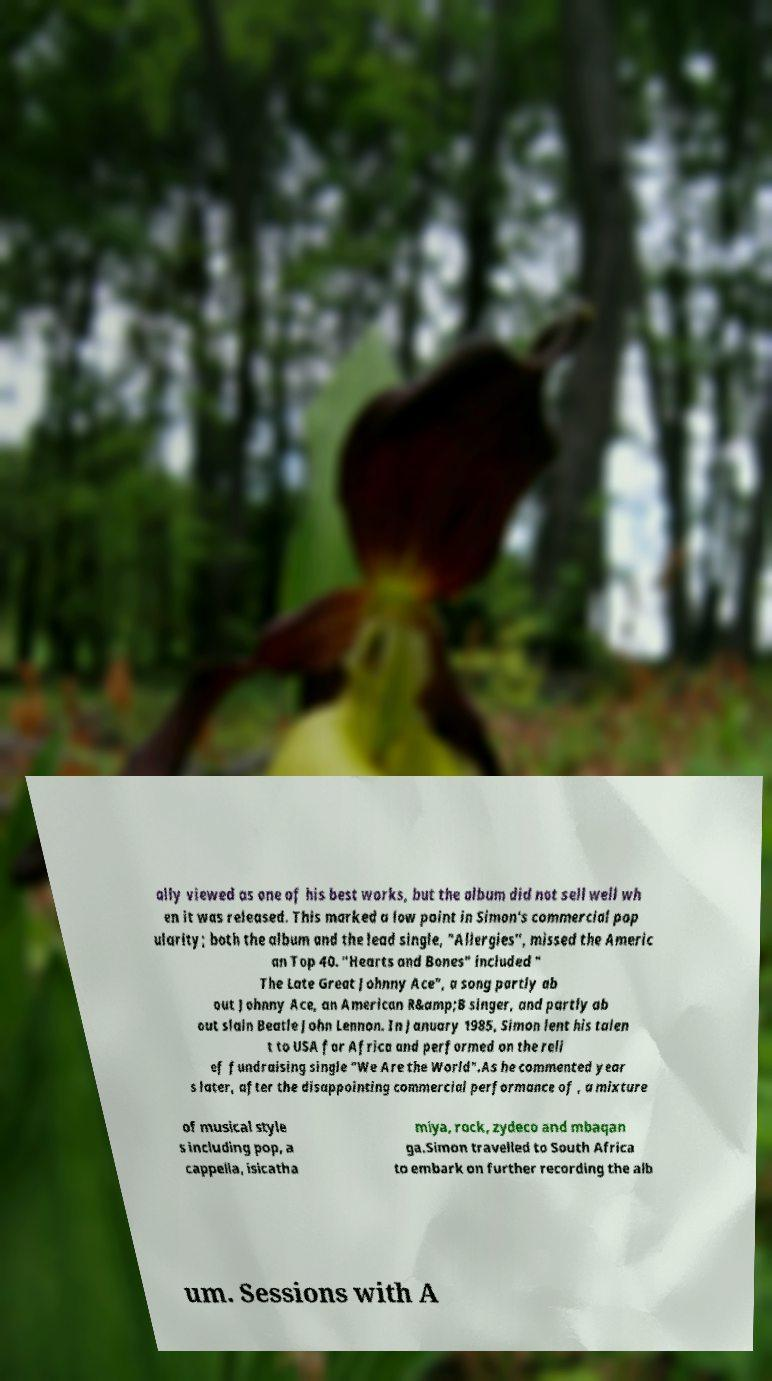I need the written content from this picture converted into text. Can you do that? ally viewed as one of his best works, but the album did not sell well wh en it was released. This marked a low point in Simon's commercial pop ularity; both the album and the lead single, "Allergies", missed the Americ an Top 40. "Hearts and Bones" included " The Late Great Johnny Ace", a song partly ab out Johnny Ace, an American R&amp;B singer, and partly ab out slain Beatle John Lennon. In January 1985, Simon lent his talen t to USA for Africa and performed on the reli ef fundraising single "We Are the World".As he commented year s later, after the disappointing commercial performance of , a mixture of musical style s including pop, a cappella, isicatha miya, rock, zydeco and mbaqan ga.Simon travelled to South Africa to embark on further recording the alb um. Sessions with A 